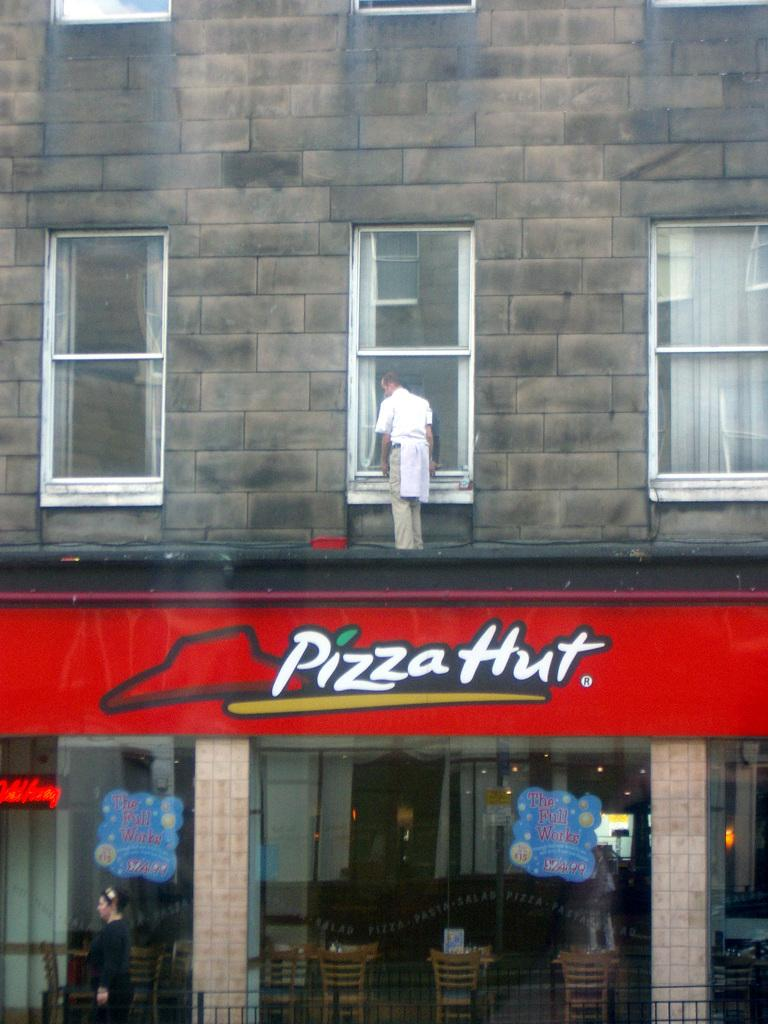What type of establishment is shown in the image? There is a Pizza Hut shop in the image. What is the man in the image doing? The man is standing on top of the shop and cleaning the glass windows. What color is the naming board in front of the shop? The naming board is red. What type of creature is the man holding in his chin while cleaning the windows? There is no creature present in the image, and the man is not holding anything in his chin while cleaning the windows. 